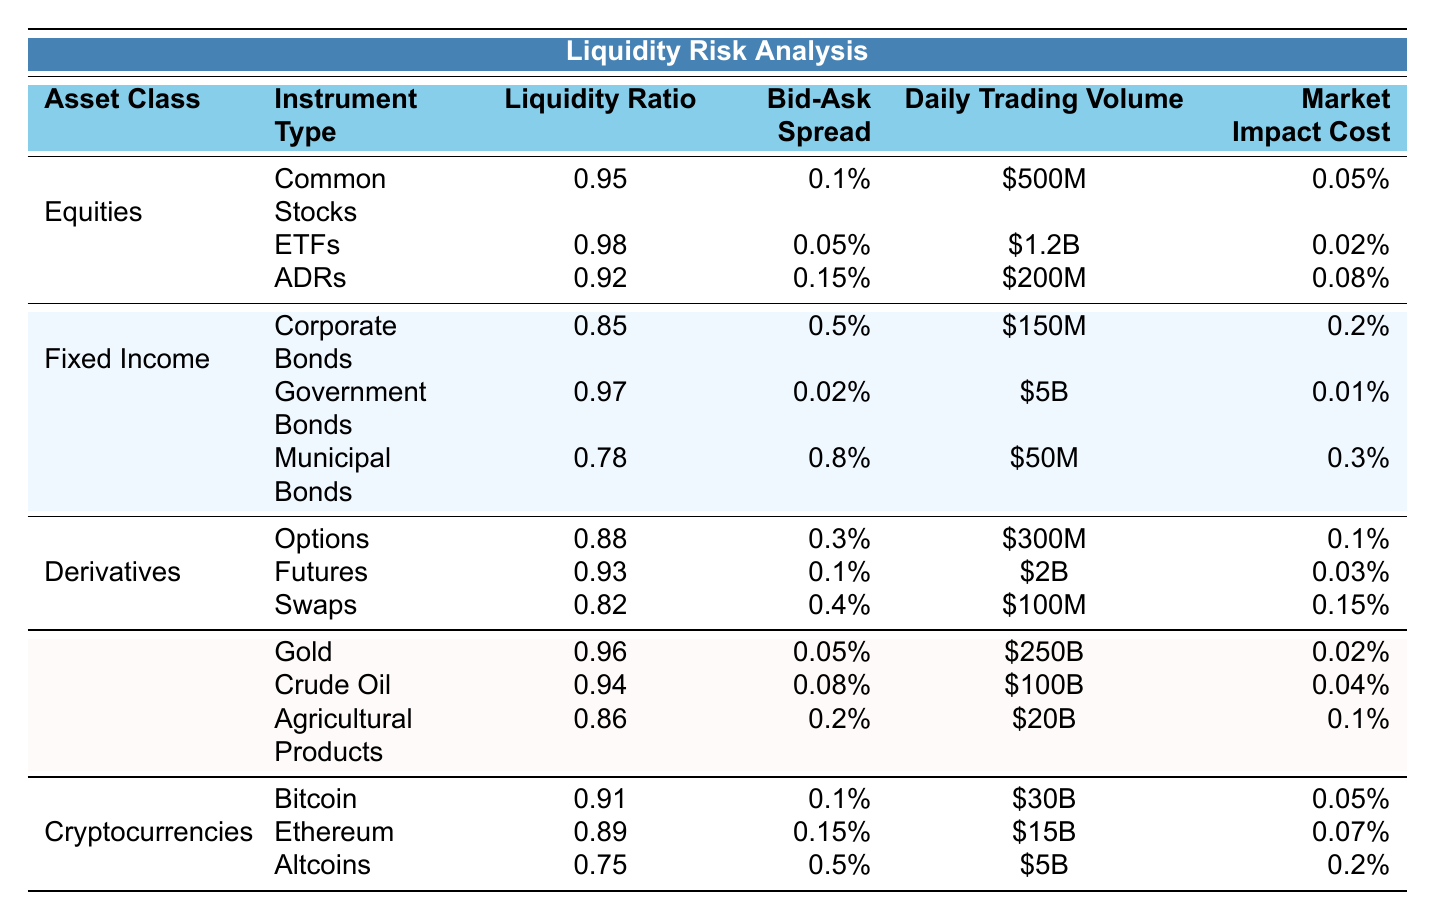What is the liquidity ratio for ETFs? The liquidity ratio for ETFs is explicitly stated in the table under the "Liquidity Ratio" column for the "ETFs" row, which shows a value of 0.98.
Answer: 0.98 Which asset class has the highest daily trading volume? The daily trading volume values for each asset class can be compared. Government Bonds have the highest trading volume at $5B, which is greater than any other asset class.
Answer: Government Bonds What is the average liquidity ratio for derivatives? The liquidity ratios for derivatives (Options = 0.88, Futures = 0.93, Swaps = 0.82) can be summed (0.88 + 0.93 + 0.82 = 2.63) and divided by 3 (2.63 / 3 = 0.8767). Rounding gives an average of approximately 0.88.
Answer: 0.88 Is the market impact cost higher for municipal bonds compared to government bonds? By comparing the market impact costs (0.3% for municipal bonds vs. 0.01% for government bonds), it's clear that 0.3% is higher than 0.01%.
Answer: Yes What is the total daily trading volume for cryptocurrencies? The daily trading volumes for the three cryptocurrency instruments (Bitcoin = $30B, Ethereum = $15B, Altcoins = $5B) can be summed (30 + 15 + 5 = 50B).
Answer: $50B Which instrument type has the lowest liquidity ratio in the table? The liquidity ratios are compared across all instruments. Municipal Bonds have the lowest liquidity ratio at 0.78.
Answer: Municipal Bonds If we compare the bid-ask spreads, which asset class has the highest average spread? The bid-ask spreads for the instruments are evaluated. For Fixed Income: (0.5% + 0.02% + 0.8%) / 3 = 0.4367%. For Commodities: (0.05% + 0.08% + 0.2%) / 3 = 0.1133%. The highest average spread is for Fixed Income, approximately 0.44%.
Answer: Fixed Income Are the liquidity ratios for cryptocurrencies predominantly above or below 0.90? The liquidity ratios for Bitcoin (0.91), Ethereum (0.89), and Altcoins (0.75) show that only one instrument (Bitcoin) is above 0.90, while two are below. Therefore, most are below 0.90.
Answer: Below What's the difference in market impact costs between crude oil and gold? The market impact costs are 0.04% for crude oil and 0.02% for gold. The difference is calculated (0.04% - 0.02% = 0.02%).
Answer: 0.02% Which type of equities has the lowest bid-ask spread? The bid-ask spreads for equities are compared: Common Stocks (0.1%), ETFs (0.05%), and ADRs (0.15%). ETFs have the lowest spread at 0.05%.
Answer: ETFs 